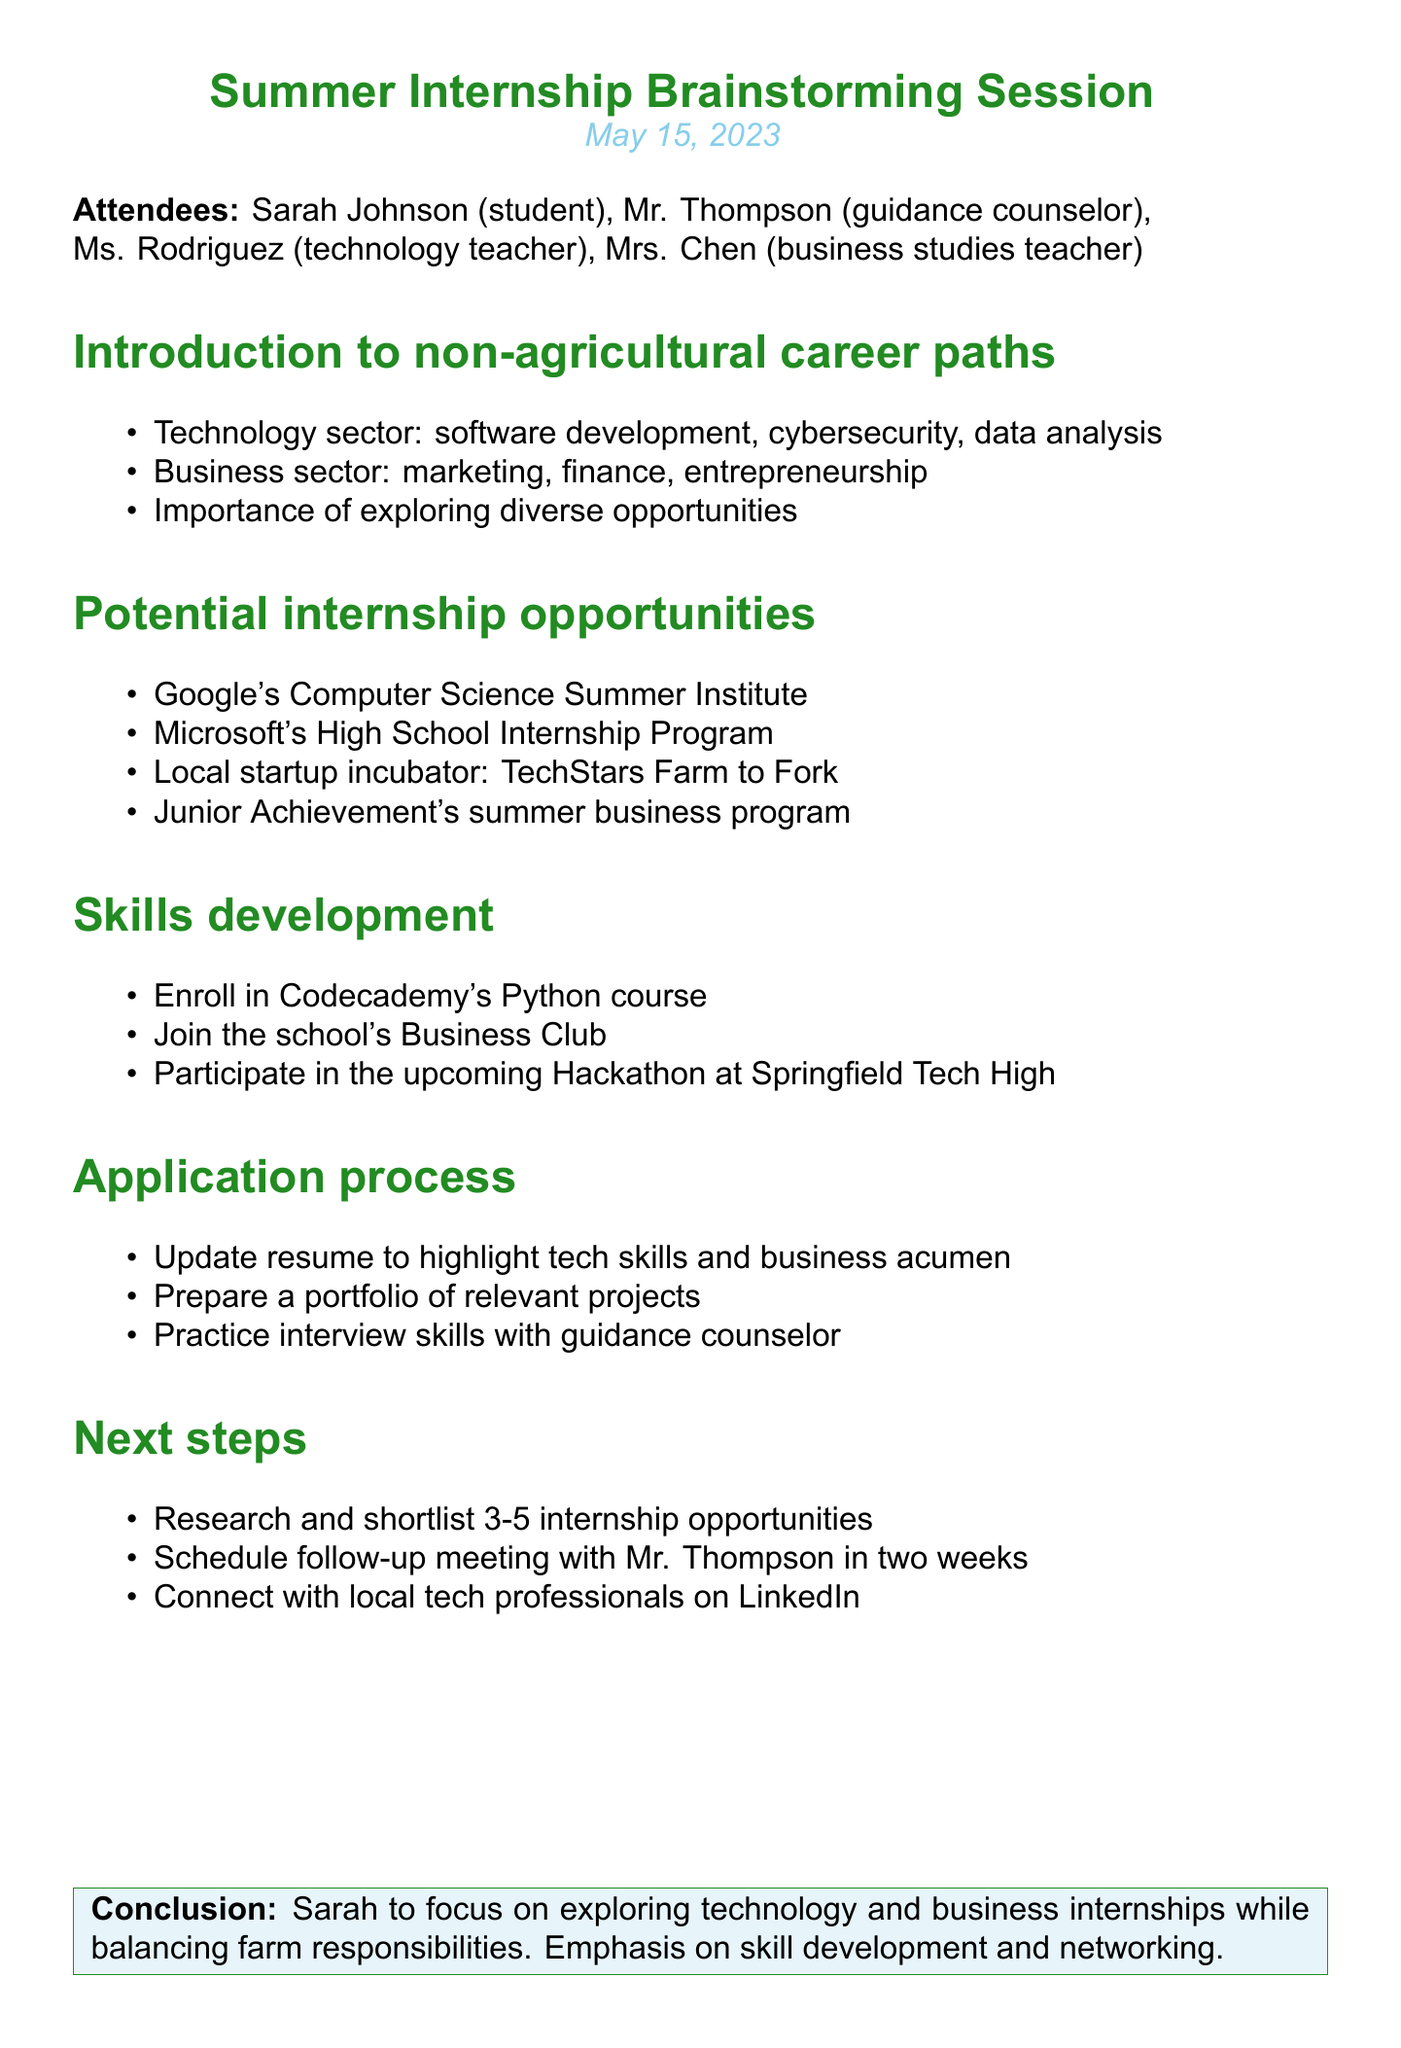What is the date of the meeting? The date of the meeting is stated at the beginning of the document, which is May 15, 2023.
Answer: May 15, 2023 Who is the guidance counselor that attended the meeting? The document lists attendees, including Mr. Thompson, who is identified as the guidance counselor.
Answer: Mr. Thompson What is one suggested internship opportunity mentioned? The document includes a section on potential internship opportunities where suggestions like Google's Computer Science Summer Institute are listed.
Answer: Google's Computer Science Summer Institute What is one action item related to skills development? Skills development action items include enrolling in Codecademy's Python course as mentioned in the document.
Answer: Enroll in Codecademy's Python course How many internship opportunities should Sarah shortlist? The document specifies that Sarah should research and shortlist 3-5 internship opportunities.
Answer: 3-5 What is the focus of the conclusion? The conclusion summarizes the outcome of the meeting with a focus on Sarah's exploration of technology and business internships while balancing farm responsibilities.
Answer: Technology and business internships What was one of the topics discussed in the meeting? The agenda includes multiple topics, one of which is "Potential internship opportunities" discussed during the session.
Answer: Potential internship opportunities What action should Sarah take regarding her resume? The document suggests that Sarah should update her resume to highlight tech skills and business acumen.
Answer: Update resume 